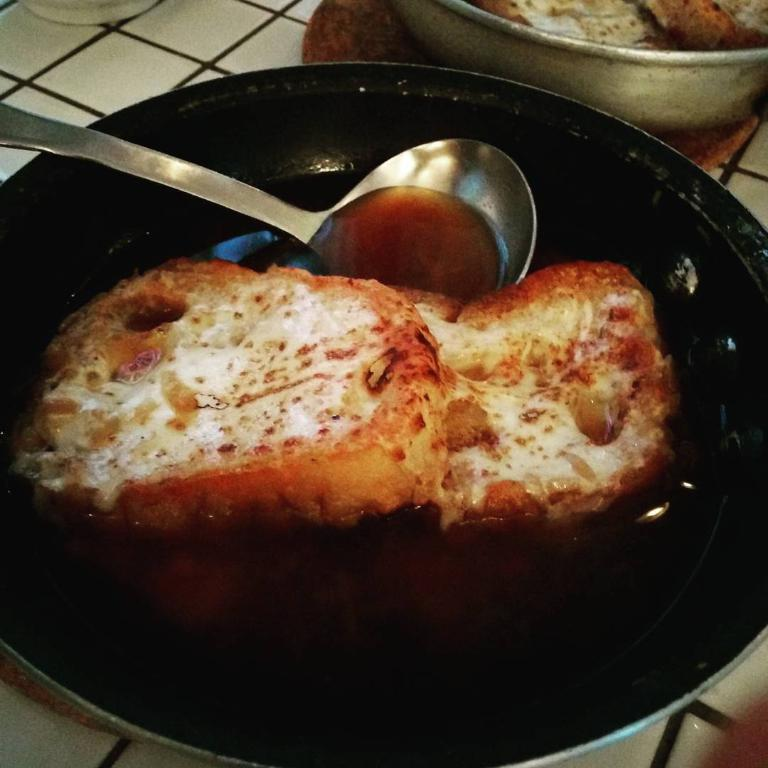What can be seen in the image related to food? There is food in the image. What utensil is present in the image? There is a spoon in the bowl. What sign can be seen on the food in the image? There is no sign visible on the food in the image. What type of ornament is present on the spoon in the image? There is no ornament present on the spoon in the image. 